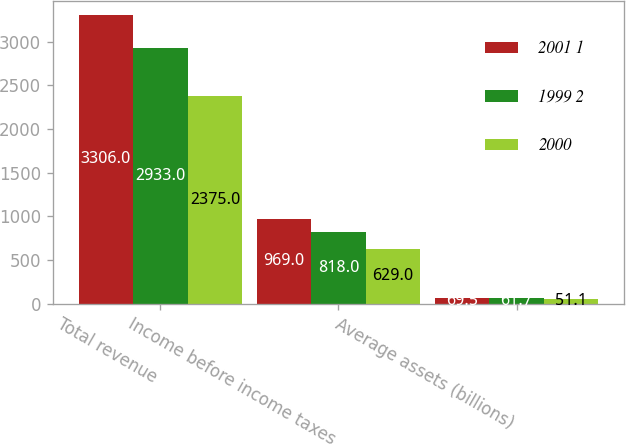<chart> <loc_0><loc_0><loc_500><loc_500><stacked_bar_chart><ecel><fcel>Total revenue<fcel>Income before income taxes<fcel>Average assets (billions)<nl><fcel>2001 1<fcel>3306<fcel>969<fcel>69.5<nl><fcel>1999 2<fcel>2933<fcel>818<fcel>61.7<nl><fcel>2000<fcel>2375<fcel>629<fcel>51.1<nl></chart> 